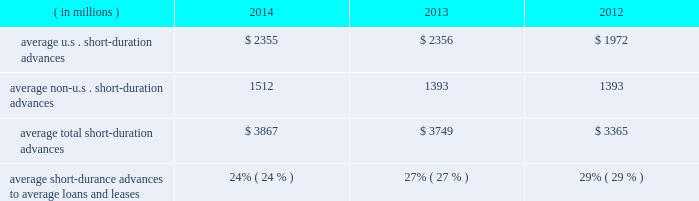Management 2019s discussion and analysis of financial condition and results of operations ( continued ) detail with respect to our investment portfolio as of december 31 , 2014 and 2013 is provided in note 3 to the consolidated financial statements included under item 8 of this form 10-k .
Loans and leases averaged $ 15.91 billion for the year ended 2014 , up from $ 13.78 billion in 2013 .
The increase was mainly related to mutual fund lending and our continued investment in senior secured bank loans .
Mutual fund lending and senior secured bank loans averaged approximately $ 9.12 billion and $ 1.40 billion , respectively , for the year ended december 31 , 2014 compared to $ 8.16 billion and $ 170 million for the year ended december 31 , 2013 , respectively .
Average loans and leases also include short- duration advances .
Table 13 : u.s .
And non-u.s .
Short-duration advances years ended december 31 .
Average u.s .
Short-duration advances $ 2355 $ 2356 $ 1972 average non-u.s .
Short-duration advances 1512 1393 1393 average total short-duration advances $ 3867 $ 3749 $ 3365 average short-durance advances to average loans and leases 24% ( 24 % ) 27% ( 27 % ) 29% ( 29 % ) the decline in proportion of the average daily short-duration advances to average loans and leases is primarily due to growth in the other segments of the loan and lease portfolio .
Short-duration advances provide liquidity to clients in support of their investment activities .
Although average short-duration advances for the year ended december 31 , 2014 increased compared to the year ended december 31 , 2013 , such average advances remained low relative to historical levels , mainly the result of clients continuing to hold higher levels of liquidity .
Average other interest-earning assets increased to $ 15.94 billion for the year ended december 31 , 2014 from $ 11.16 billion for the year ended december 31 , 2013 .
The increased levels were primarily the result of higher levels of cash collateral provided in connection with our enhanced custody business .
Aggregate average interest-bearing deposits increased to $ 130.30 billion for the year ended december 31 , 2014 from $ 109.25 billion for year ended 2013 .
The higher levels were primarily the result of increases in both u.s .
And non-u.s .
Transaction accounts and time deposits .
Future transaction account levels will be influenced by the underlying asset servicing business , as well as market conditions , including the general levels of u.s .
And non-u.s .
Interest rates .
Average other short-term borrowings increased to $ 4.18 billion for the year ended december 31 , 2014 from $ 3.79 billion for the year ended 2013 .
The increase was the result of a higher level of client demand for our commercial paper .
The decline in rates paid from 1.6% ( 1.6 % ) in 2013 to 0.1% ( 0.1 % ) in 2014 resulted from a reclassification of certain derivative contracts that hedge our interest-rate risk on certain assets and liabilities , which reduced interest revenue and interest expense .
Average long-term debt increased to $ 9.31 billion for the year ended december 31 , 2014 from $ 8.42 billion for the year ended december 31 , 2013 .
The increase primarily reflected the issuance of $ 1.5 billion of senior and subordinated debt in may 2013 , $ 1.0 billion of senior debt issued in november 2013 , and $ 1.0 billion of senior debt issued in december 2014 .
This is partially offset by the maturities of $ 500 million of senior debt in may 2014 and $ 250 million of senior debt in march 2014 .
Average other interest-bearing liabilities increased to $ 7.35 billion for the year ended december 31 , 2014 from $ 6.46 billion for the year ended december 31 , 2013 , primarily the result of higher levels of cash collateral received from clients in connection with our enhanced custody business .
Several factors could affect future levels of our net interest revenue and margin , including the mix of client liabilities ; actions of various central banks ; changes in u.s .
And non-u.s .
Interest rates ; changes in the various yield curves around the world ; revised or proposed regulatory capital or liquidity standards , or interpretations of those standards ; the amount of discount accretion generated by the former conduit securities that remain in our investment securities portfolio ; and the yields earned on securities purchased compared to the yields earned on securities sold or matured .
Based on market conditions and other factors , we continue to reinvest the majority of the proceeds from pay-downs and maturities of investment securities in highly-rated securities , such as u.s .
Treasury and agency securities , municipal securities , federal agency mortgage-backed securities and u.s .
And non-u.s .
Mortgage- and asset-backed securities .
The pace at which we continue to reinvest and the types of investment securities purchased will depend on the impact of market conditions and other factors over time .
We expect these factors and the levels of global interest rates to influence what effect our reinvestment program will have on future levels of our net interest revenue and net interest margin. .
What is the percentage change in the average total short-duration advances from 2013 to 2014? 
Computations: ((3867 - 3749) / 3749)
Answer: 0.03148. 